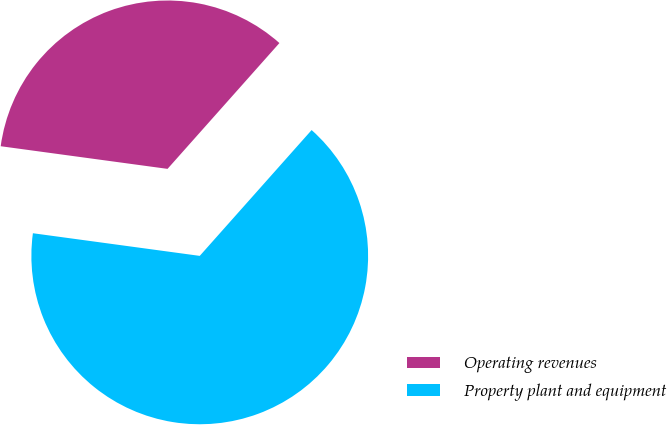<chart> <loc_0><loc_0><loc_500><loc_500><pie_chart><fcel>Operating revenues<fcel>Property plant and equipment<nl><fcel>34.42%<fcel>65.58%<nl></chart> 